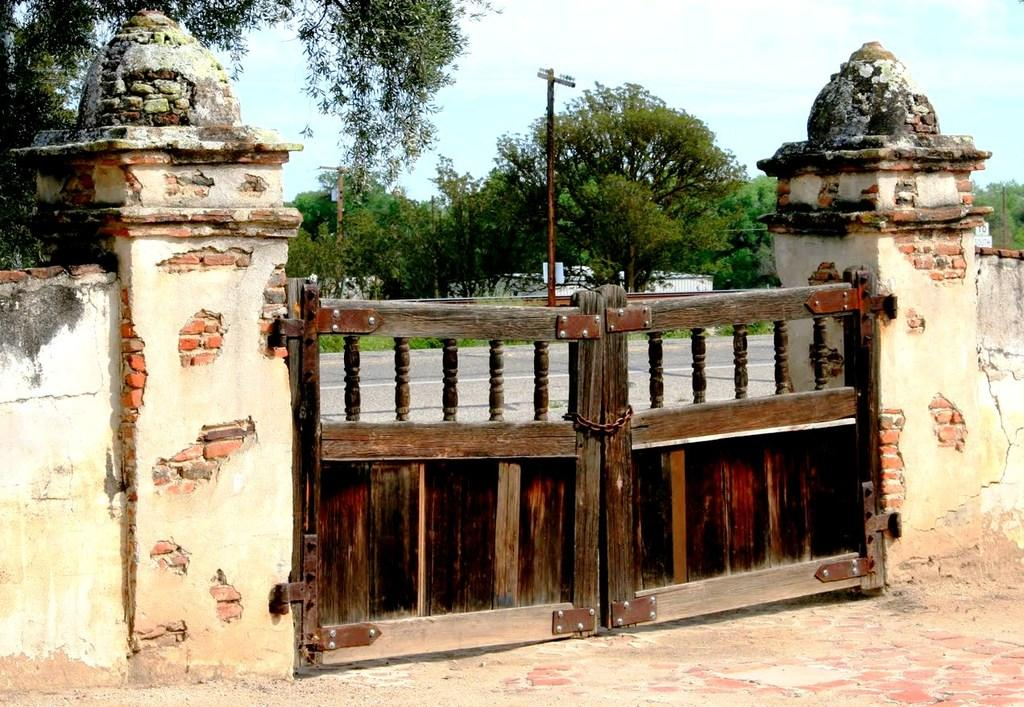What structure can be seen in the image? There is a gate in the image. What else is present in the image besides the gate? There are walls in the image. What can be seen in the background of the image? In the background, there are poles, trees, houses, and clouds visible in the sky. What type of basin is used to collect rainwater in the image? There is no basin present in the image to collect rainwater. How does the nerve system of the trees in the background affect their growth in the image? There is no mention of the trees' nerve system in the image, and it is not relevant to their growth. 